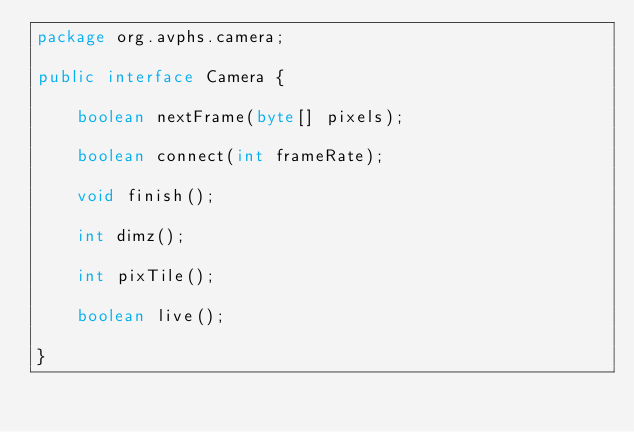<code> <loc_0><loc_0><loc_500><loc_500><_Java_>package org.avphs.camera;

public interface Camera {

    boolean nextFrame(byte[] pixels);

    boolean connect(int frameRate);

    void finish();

    int dimz();

    int pixTile();

    boolean live();

}
</code> 